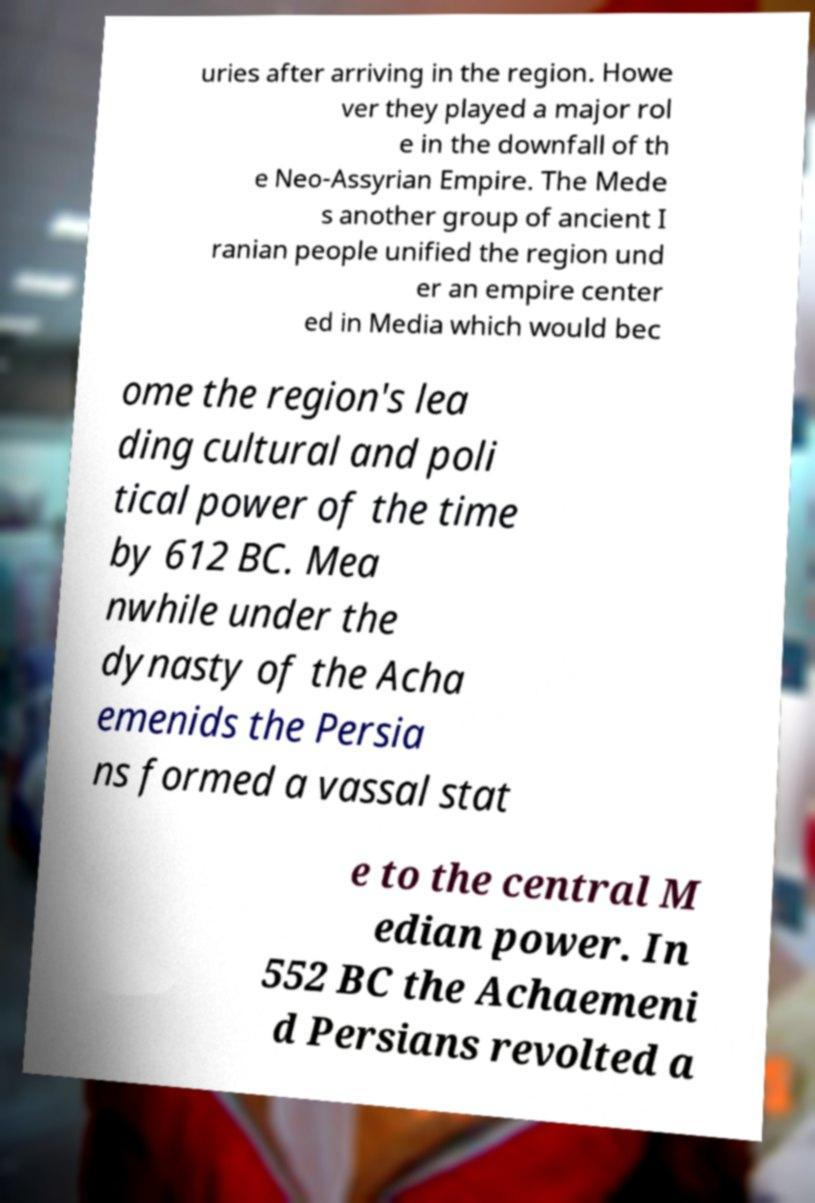Please read and relay the text visible in this image. What does it say? uries after arriving in the region. Howe ver they played a major rol e in the downfall of th e Neo-Assyrian Empire. The Mede s another group of ancient I ranian people unified the region und er an empire center ed in Media which would bec ome the region's lea ding cultural and poli tical power of the time by 612 BC. Mea nwhile under the dynasty of the Acha emenids the Persia ns formed a vassal stat e to the central M edian power. In 552 BC the Achaemeni d Persians revolted a 